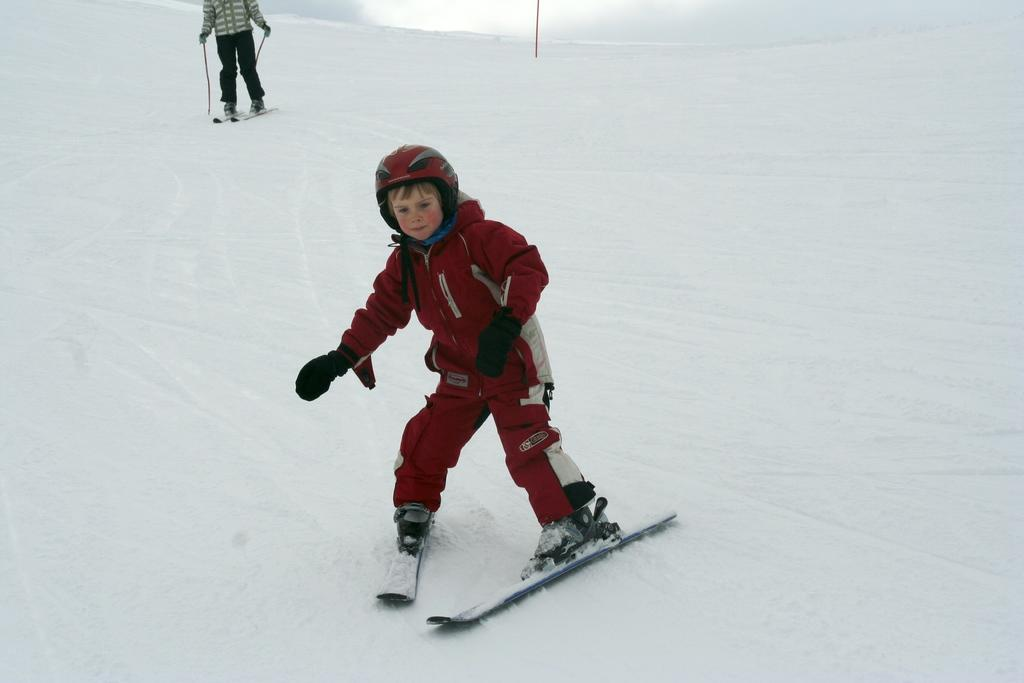What activity are the two persons in the image engaged in? The two persons in the image are skiing. What is the surface on which they are skiing? The skiing is taking place on snow. What protective gear is the front person wearing? The front person is wearing a helmet and gloves. What can be seen in the background of the image? There is a pole visible in the background of the image. What is the overall setting of the image? The background of the image consists of snow. What type of sweater is the passenger wearing in the image? There is no passenger present in the image, and therefore no sweater can be observed. 